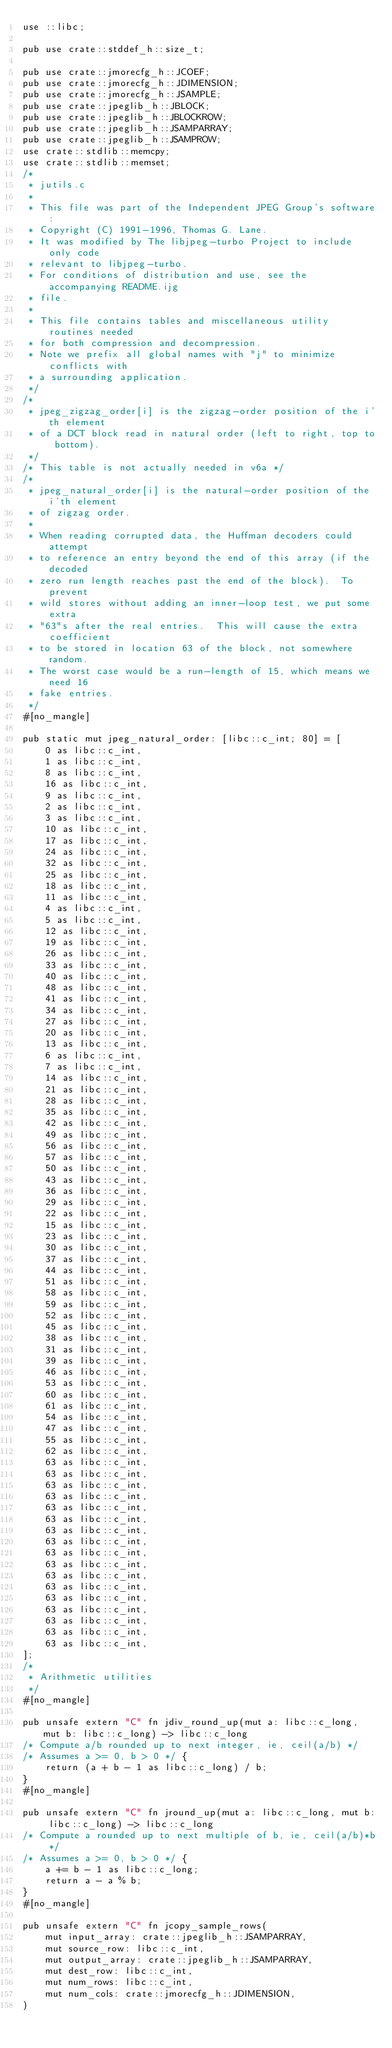Convert code to text. <code><loc_0><loc_0><loc_500><loc_500><_Rust_>use ::libc;

pub use crate::stddef_h::size_t;

pub use crate::jmorecfg_h::JCOEF;
pub use crate::jmorecfg_h::JDIMENSION;
pub use crate::jmorecfg_h::JSAMPLE;
pub use crate::jpeglib_h::JBLOCK;
pub use crate::jpeglib_h::JBLOCKROW;
pub use crate::jpeglib_h::JSAMPARRAY;
pub use crate::jpeglib_h::JSAMPROW;
use crate::stdlib::memcpy;
use crate::stdlib::memset;
/*
 * jutils.c
 *
 * This file was part of the Independent JPEG Group's software:
 * Copyright (C) 1991-1996, Thomas G. Lane.
 * It was modified by The libjpeg-turbo Project to include only code
 * relevant to libjpeg-turbo.
 * For conditions of distribution and use, see the accompanying README.ijg
 * file.
 *
 * This file contains tables and miscellaneous utility routines needed
 * for both compression and decompression.
 * Note we prefix all global names with "j" to minimize conflicts with
 * a surrounding application.
 */
/*
 * jpeg_zigzag_order[i] is the zigzag-order position of the i'th element
 * of a DCT block read in natural order (left to right, top to bottom).
 */
/* This table is not actually needed in v6a */
/*
 * jpeg_natural_order[i] is the natural-order position of the i'th element
 * of zigzag order.
 *
 * When reading corrupted data, the Huffman decoders could attempt
 * to reference an entry beyond the end of this array (if the decoded
 * zero run length reaches past the end of the block).  To prevent
 * wild stores without adding an inner-loop test, we put some extra
 * "63"s after the real entries.  This will cause the extra coefficient
 * to be stored in location 63 of the block, not somewhere random.
 * The worst case would be a run-length of 15, which means we need 16
 * fake entries.
 */
#[no_mangle]

pub static mut jpeg_natural_order: [libc::c_int; 80] = [
    0 as libc::c_int,
    1 as libc::c_int,
    8 as libc::c_int,
    16 as libc::c_int,
    9 as libc::c_int,
    2 as libc::c_int,
    3 as libc::c_int,
    10 as libc::c_int,
    17 as libc::c_int,
    24 as libc::c_int,
    32 as libc::c_int,
    25 as libc::c_int,
    18 as libc::c_int,
    11 as libc::c_int,
    4 as libc::c_int,
    5 as libc::c_int,
    12 as libc::c_int,
    19 as libc::c_int,
    26 as libc::c_int,
    33 as libc::c_int,
    40 as libc::c_int,
    48 as libc::c_int,
    41 as libc::c_int,
    34 as libc::c_int,
    27 as libc::c_int,
    20 as libc::c_int,
    13 as libc::c_int,
    6 as libc::c_int,
    7 as libc::c_int,
    14 as libc::c_int,
    21 as libc::c_int,
    28 as libc::c_int,
    35 as libc::c_int,
    42 as libc::c_int,
    49 as libc::c_int,
    56 as libc::c_int,
    57 as libc::c_int,
    50 as libc::c_int,
    43 as libc::c_int,
    36 as libc::c_int,
    29 as libc::c_int,
    22 as libc::c_int,
    15 as libc::c_int,
    23 as libc::c_int,
    30 as libc::c_int,
    37 as libc::c_int,
    44 as libc::c_int,
    51 as libc::c_int,
    58 as libc::c_int,
    59 as libc::c_int,
    52 as libc::c_int,
    45 as libc::c_int,
    38 as libc::c_int,
    31 as libc::c_int,
    39 as libc::c_int,
    46 as libc::c_int,
    53 as libc::c_int,
    60 as libc::c_int,
    61 as libc::c_int,
    54 as libc::c_int,
    47 as libc::c_int,
    55 as libc::c_int,
    62 as libc::c_int,
    63 as libc::c_int,
    63 as libc::c_int,
    63 as libc::c_int,
    63 as libc::c_int,
    63 as libc::c_int,
    63 as libc::c_int,
    63 as libc::c_int,
    63 as libc::c_int,
    63 as libc::c_int,
    63 as libc::c_int,
    63 as libc::c_int,
    63 as libc::c_int,
    63 as libc::c_int,
    63 as libc::c_int,
    63 as libc::c_int,
    63 as libc::c_int,
    63 as libc::c_int,
];
/*
 * Arithmetic utilities
 */
#[no_mangle]

pub unsafe extern "C" fn jdiv_round_up(mut a: libc::c_long, mut b: libc::c_long) -> libc::c_long
/* Compute a/b rounded up to next integer, ie, ceil(a/b) */
/* Assumes a >= 0, b > 0 */ {
    return (a + b - 1 as libc::c_long) / b;
}
#[no_mangle]

pub unsafe extern "C" fn jround_up(mut a: libc::c_long, mut b: libc::c_long) -> libc::c_long
/* Compute a rounded up to next multiple of b, ie, ceil(a/b)*b */
/* Assumes a >= 0, b > 0 */ {
    a += b - 1 as libc::c_long;
    return a - a % b;
}
#[no_mangle]

pub unsafe extern "C" fn jcopy_sample_rows(
    mut input_array: crate::jpeglib_h::JSAMPARRAY,
    mut source_row: libc::c_int,
    mut output_array: crate::jpeglib_h::JSAMPARRAY,
    mut dest_row: libc::c_int,
    mut num_rows: libc::c_int,
    mut num_cols: crate::jmorecfg_h::JDIMENSION,
)</code> 